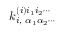<formula> <loc_0><loc_0><loc_500><loc_500>k _ { i , \, \alpha _ { 1 } \alpha _ { 2 } \cdots } ^ { ( i ) i _ { 1 } i _ { 2 } \cdots }</formula> 